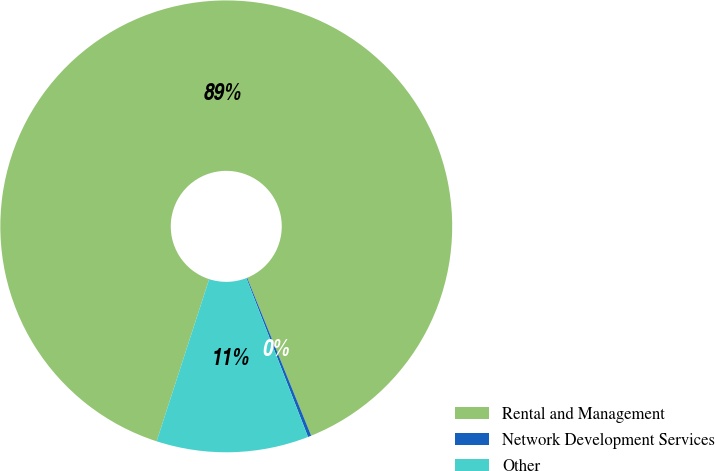<chart> <loc_0><loc_0><loc_500><loc_500><pie_chart><fcel>Rental and Management<fcel>Network Development Services<fcel>Other<nl><fcel>88.88%<fcel>0.24%<fcel>10.88%<nl></chart> 